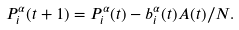Convert formula to latex. <formula><loc_0><loc_0><loc_500><loc_500>P ^ { \alpha } _ { i } ( t + 1 ) = P _ { i } ^ { \alpha } ( t ) - b ^ { \alpha } _ { i } ( t ) A ( t ) / N .</formula> 